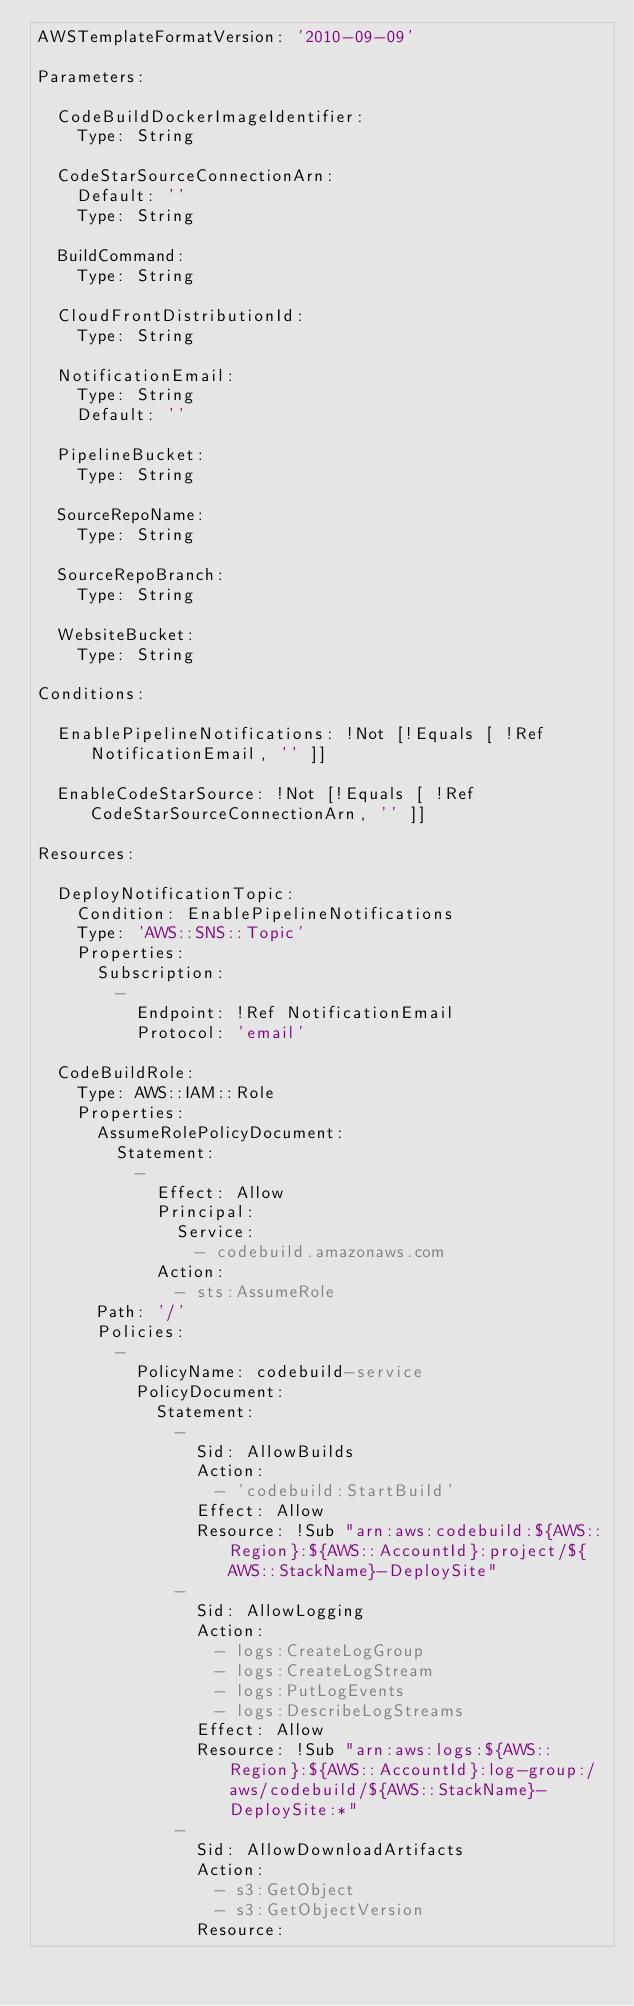<code> <loc_0><loc_0><loc_500><loc_500><_YAML_>AWSTemplateFormatVersion: '2010-09-09'

Parameters:

  CodeBuildDockerImageIdentifier:
    Type: String

  CodeStarSourceConnectionArn:
    Default: ''
    Type: String

  BuildCommand:
    Type: String

  CloudFrontDistributionId:
    Type: String

  NotificationEmail:
    Type: String
    Default: ''

  PipelineBucket:
    Type: String

  SourceRepoName:
    Type: String

  SourceRepoBranch:
    Type: String

  WebsiteBucket:
    Type: String

Conditions:

  EnablePipelineNotifications: !Not [!Equals [ !Ref NotificationEmail, '' ]]

  EnableCodeStarSource: !Not [!Equals [ !Ref CodeStarSourceConnectionArn, '' ]]

Resources:

  DeployNotificationTopic:
    Condition: EnablePipelineNotifications
    Type: 'AWS::SNS::Topic'
    Properties:
      Subscription:
        -
          Endpoint: !Ref NotificationEmail
          Protocol: 'email'

  CodeBuildRole:
    Type: AWS::IAM::Role
    Properties:
      AssumeRolePolicyDocument:
        Statement:
          -
            Effect: Allow
            Principal:
              Service:
                - codebuild.amazonaws.com
            Action:
              - sts:AssumeRole
      Path: '/'
      Policies:
        -
          PolicyName: codebuild-service
          PolicyDocument:
            Statement:
              -
                Sid: AllowBuilds
                Action:
                  - 'codebuild:StartBuild'
                Effect: Allow
                Resource: !Sub "arn:aws:codebuild:${AWS::Region}:${AWS::AccountId}:project/${AWS::StackName}-DeploySite"
              -
                Sid: AllowLogging
                Action:
                  - logs:CreateLogGroup
                  - logs:CreateLogStream
                  - logs:PutLogEvents
                  - logs:DescribeLogStreams
                Effect: Allow
                Resource: !Sub "arn:aws:logs:${AWS::Region}:${AWS::AccountId}:log-group:/aws/codebuild/${AWS::StackName}-DeploySite:*"
              -
                Sid: AllowDownloadArtifacts
                Action:
                  - s3:GetObject
                  - s3:GetObjectVersion
                Resource:</code> 